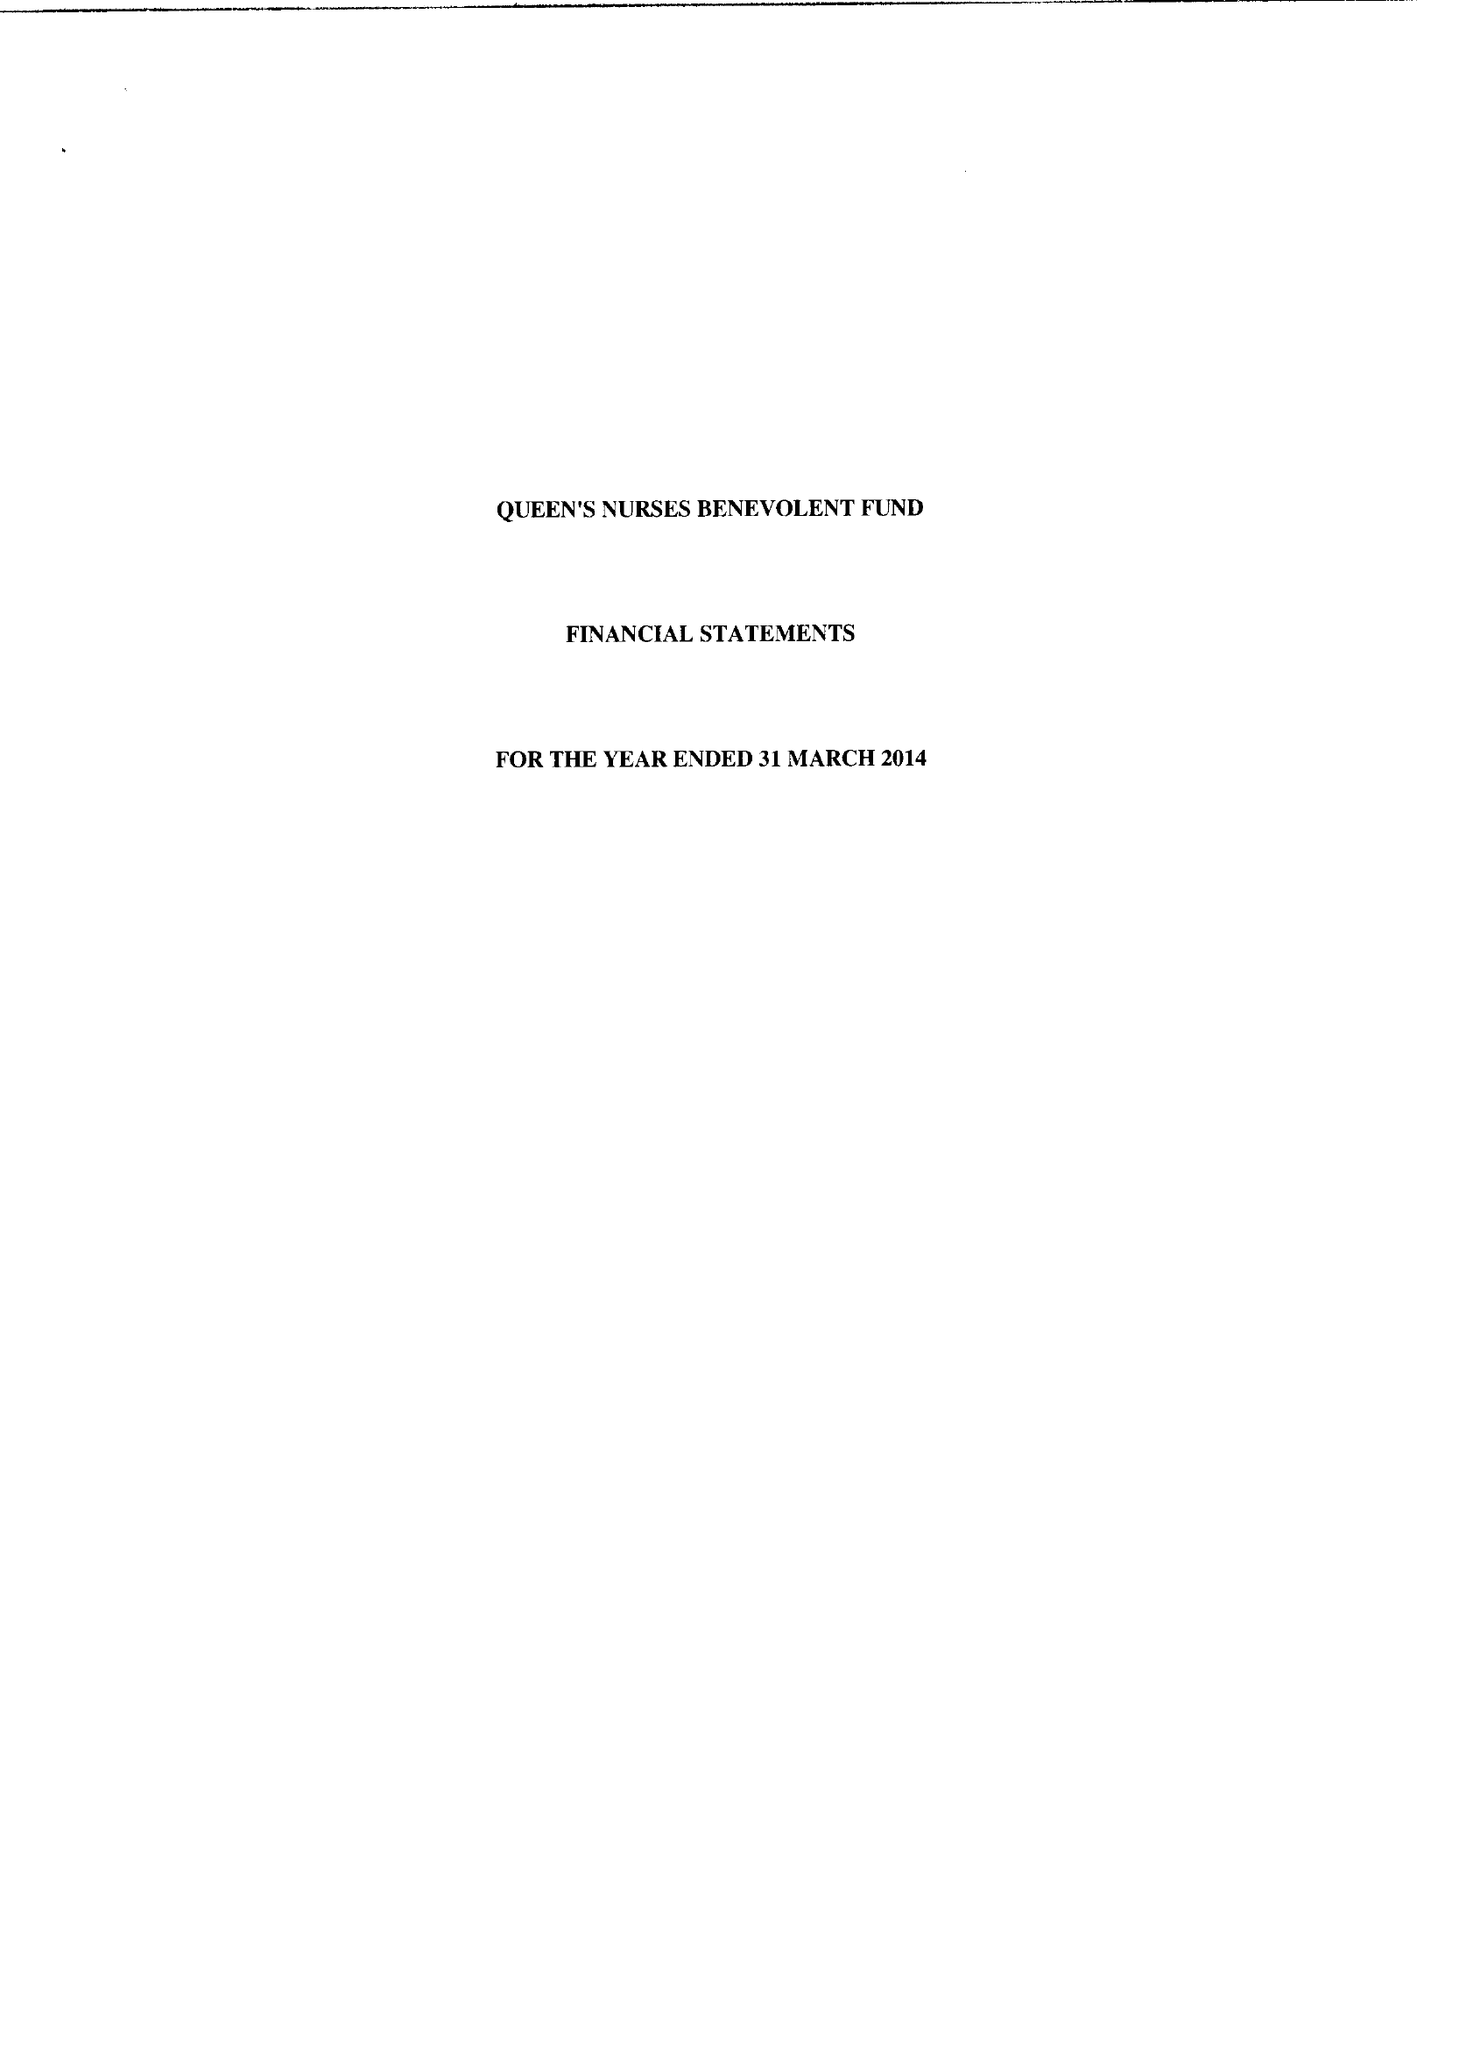What is the value for the income_annually_in_british_pounds?
Answer the question using a single word or phrase. 29349.00 